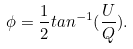<formula> <loc_0><loc_0><loc_500><loc_500>\phi = \frac { 1 } { 2 } t a n ^ { - 1 } ( \frac { U } { Q } ) .</formula> 